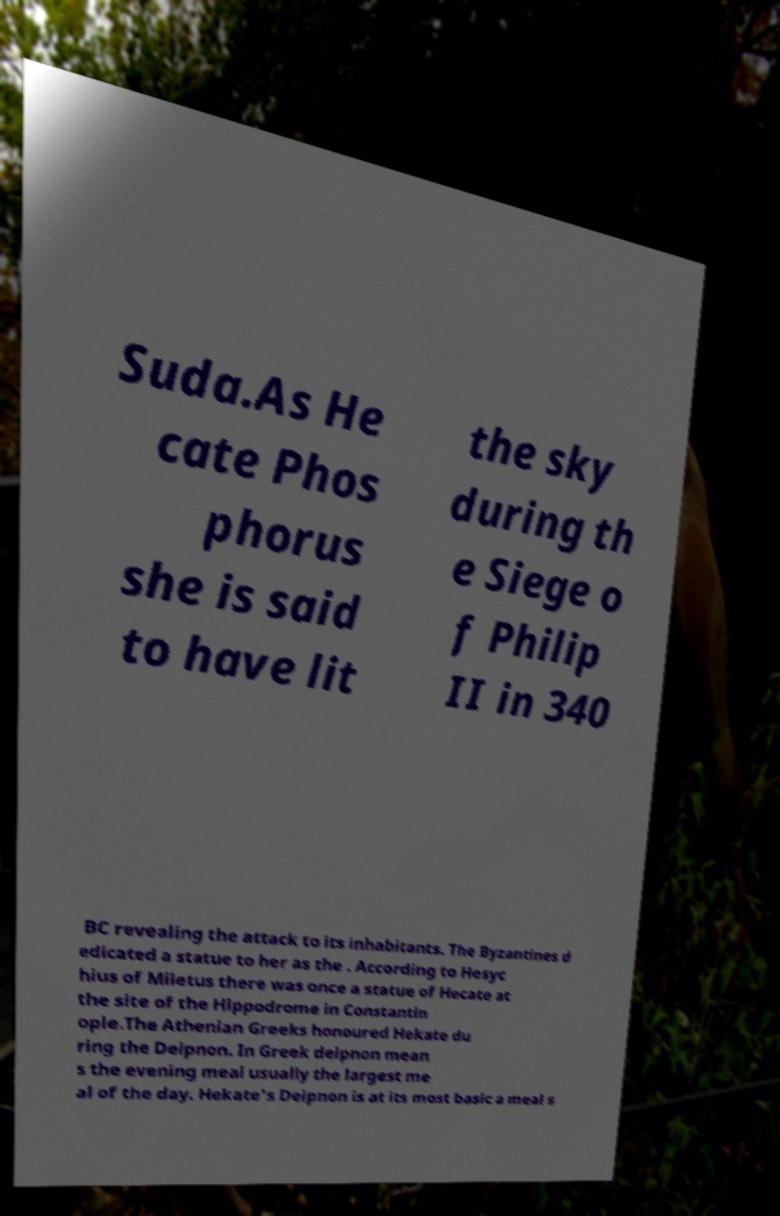Could you assist in decoding the text presented in this image and type it out clearly? Suda.As He cate Phos phorus she is said to have lit the sky during th e Siege o f Philip II in 340 BC revealing the attack to its inhabitants. The Byzantines d edicated a statue to her as the . According to Hesyc hius of Miletus there was once a statue of Hecate at the site of the Hippodrome in Constantin ople.The Athenian Greeks honoured Hekate du ring the Deipnon. In Greek deipnon mean s the evening meal usually the largest me al of the day. Hekate's Deipnon is at its most basic a meal s 